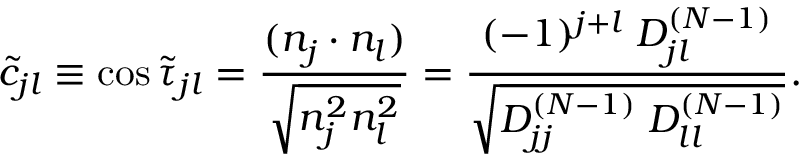Convert formula to latex. <formula><loc_0><loc_0><loc_500><loc_500>\widetilde { c } _ { j l } \equiv \cos \widetilde { \tau } _ { j l } = \frac { ( n _ { j } \cdot n _ { l } ) } { \sqrt { n _ { j } ^ { 2 } n _ { l } ^ { 2 } } } = \frac { ( - 1 ) ^ { j + l } \, D _ { j l } ^ { ( N - 1 ) } } { \sqrt { D _ { j j } ^ { ( N - 1 ) } \, D _ { l l } ^ { ( N - 1 ) } } } .</formula> 